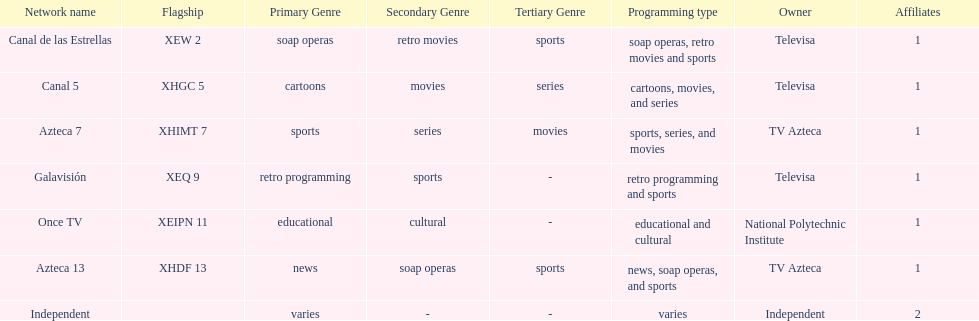What is the total number of affiliates among all the networks? 8. 